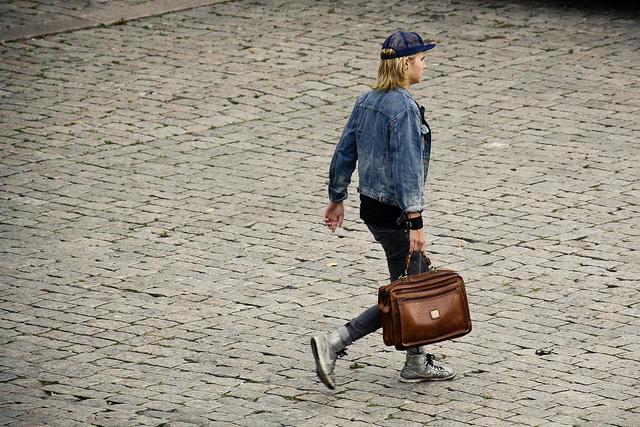Is a shadow cast?
Quick response, please. No. Is this a man or woman?
Be succinct. Woman. What color jacket is the person wearing?
Be succinct. Blue. How many feet are shown?
Short answer required. 2. What type of footwear is the girl wearing?
Answer briefly. Sneakers. What is the street made of?
Write a very short answer. Brick. 